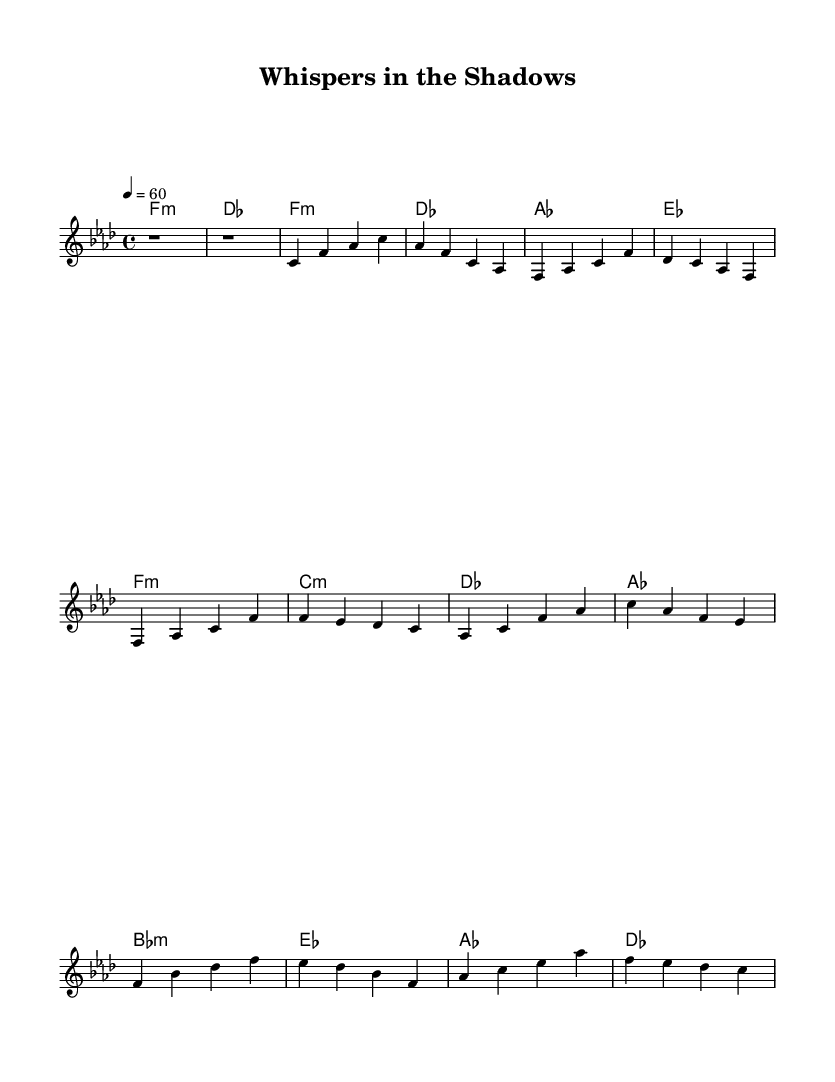What is the key signature of this music? The key signature is indicated by the number of flats or sharps at the beginning of the staff. In this piece, there is a flat symbol for B, E, and A, which indicates that it is in F minor.
Answer: F minor What is the time signature of this piece? The time signature appears at the beginning of the staff and is indicated as a fraction. In this case, it is shown as four beats in a measure, making it 4/4.
Answer: 4/4 What is the tempo marking of the piece? The tempo is indicated at the start with the number of beats per minute. Here, it is marked as "4 = 60", which means there are 60 beats in a minute.
Answer: 60 How many measures are in the chorus section? To find the number of measures in the chorus, one can count the measure lines in that section. The chorus consists of four distinct measures.
Answer: 4 What is the first chord in the piece? The first chord is found in the intro section, where it is indicated below the staff. The first chord is F minor.
Answer: F minor Which chord follows the first in the verse? The second chord follows the first in the sequence presented in the verse section. By analyzing the chords listed, it is clear that the chord following F minor is D flat major.
Answer: D flat major What theme is primarily explored in the lyrics of this ballad? The thematic content revolves around emotional struggles related to secrecy and betrayal, which is common in soul ballads of this era. This can be inferred from the title and the context of the song.
Answer: Secrecy and betrayal 